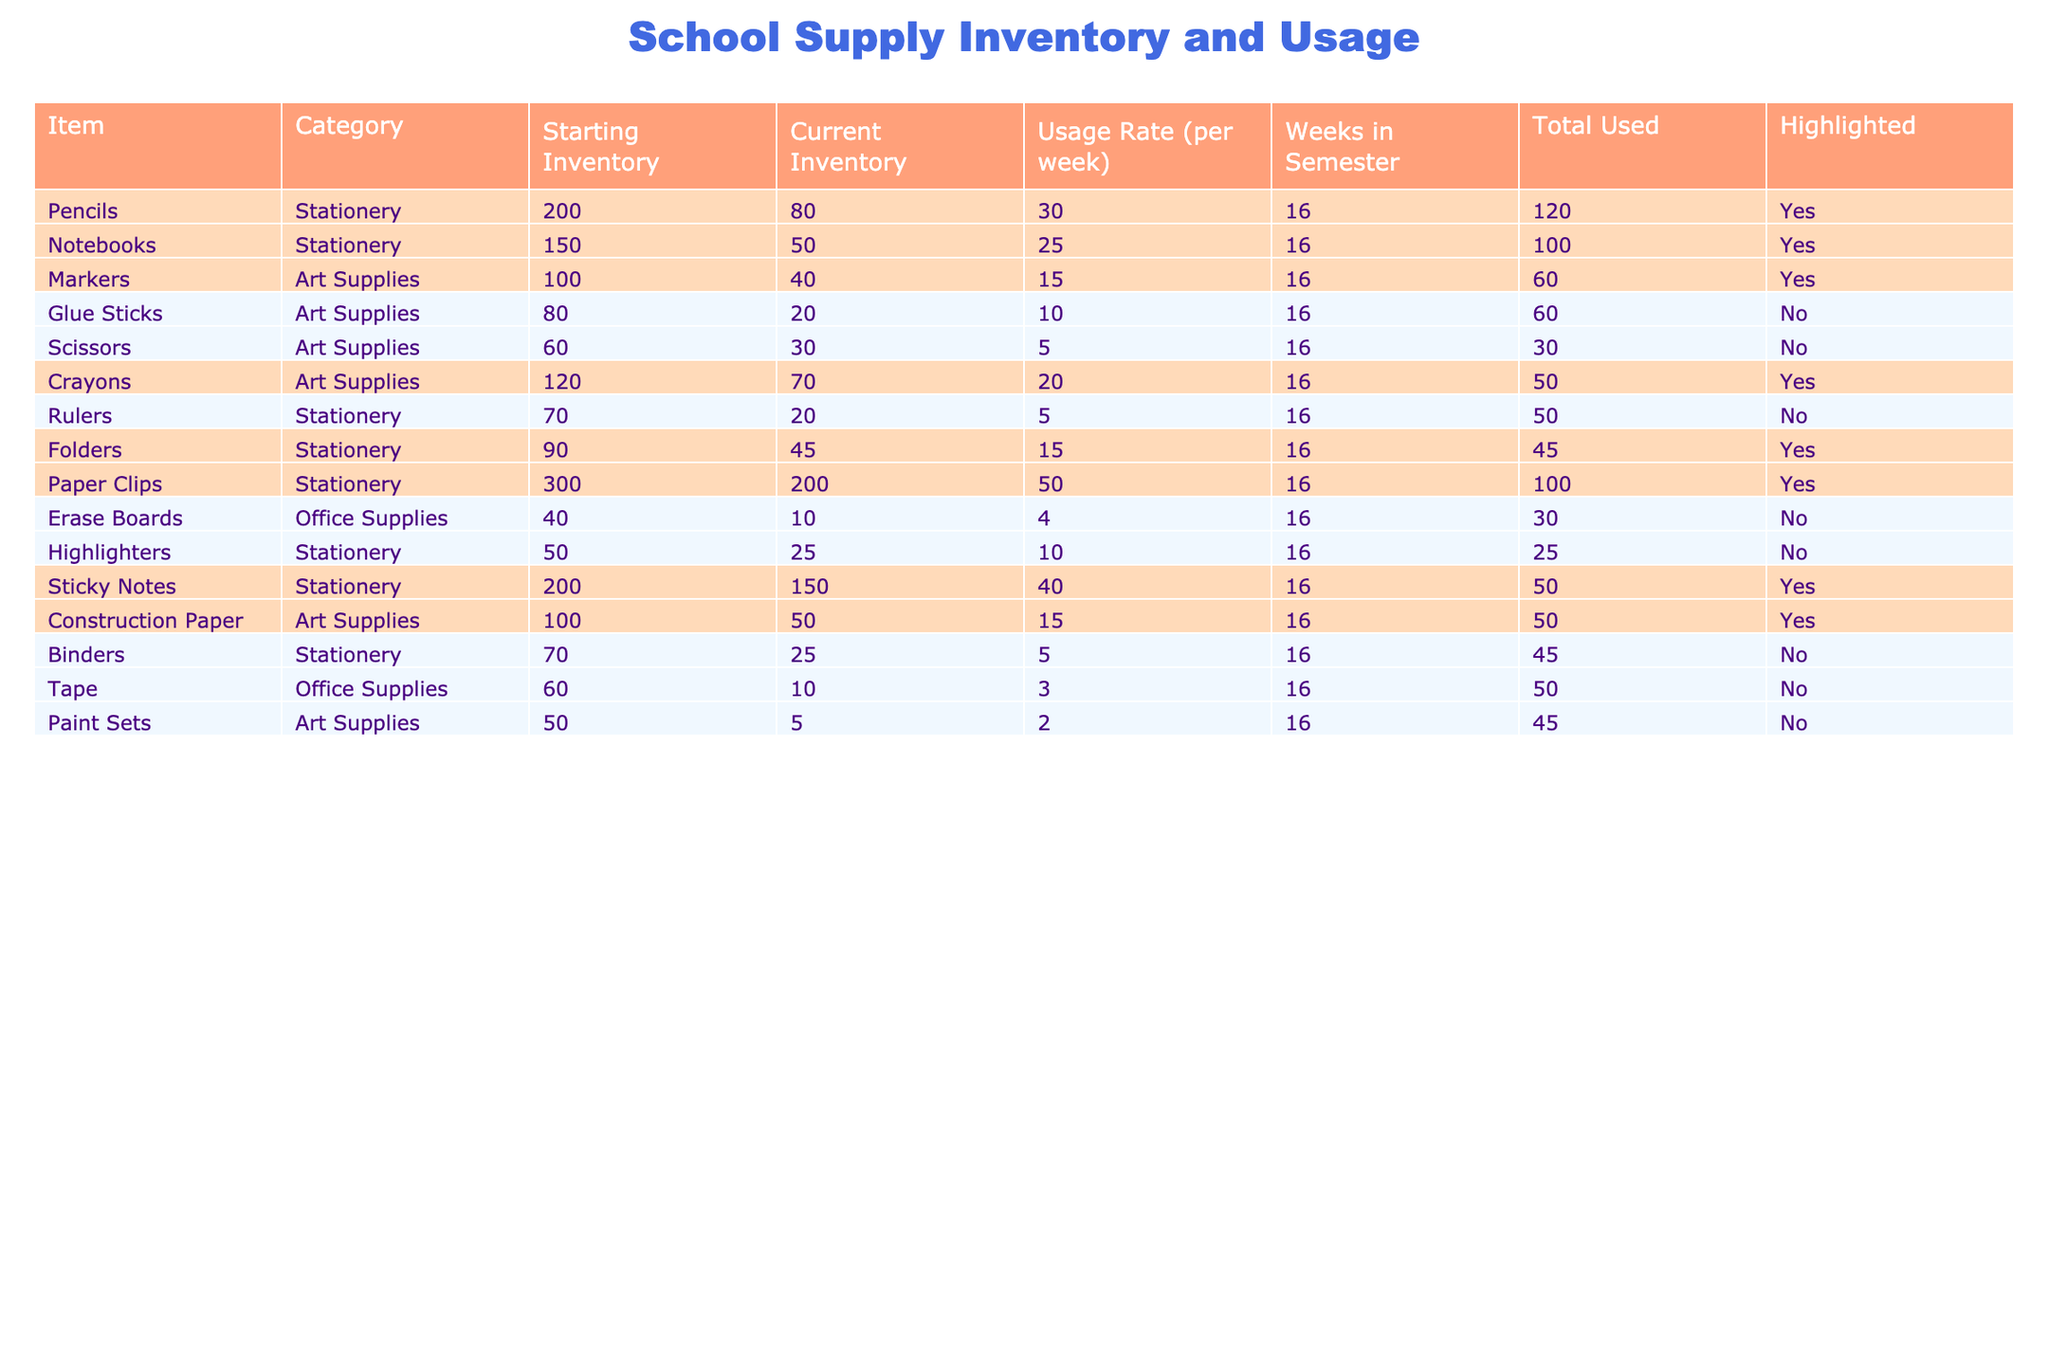What is the starting inventory of Pencils? The starting inventory of Pencils is listed in the table under the "Starting Inventory" column, where it shows a value of 200.
Answer: 200 How many Notebooks have been used this semester? The total used for Notebooks is provided in the "Total Used" column, where it states that 400 Notebooks have been used.
Answer: 400 Which item currently has the highest usage rate per week? By comparing the "Usage Rate (per week)" column, the item with the highest rate is Pencils with a usage rate of 30.
Answer: Pencils How many total Crayons are currently in inventory? The current inventory of Crayons is found in the "Current Inventory" column, showing a total of 70.
Answer: 70 Is the total used for Glue Sticks greater than 150? Looking at the "Total Used" column for Glue Sticks, the total used is 160, which is indeed greater than 150.
Answer: Yes What is the total inventory left for Stationery items after usage? Summing the current inventories for Stationery (Pencils, Notebooks, Rulers, Folders, Paper Clips, and Highlighters) gives (80 + 50 + 20 + 45 + 200 + 25 = 420).
Answer: 420 Which Art Supplies item has the lowest current inventory? By examining the "Current Inventory" for Art Supplies, Paint Sets have the lowest inventory at 5.
Answer: Paint Sets Calculate the total number of items highlighted in the table. The highlighted items are Pencils, Notebooks, Markers, Crayons, Folders, Paper Clips, Sticky Notes, and Construction Paper, totaling 8 items.
Answer: 8 What is the total amount of inventory remaining for all items classified as Office Supplies? The remaining inventory for Office Supplies (Erase Boards and Tape) totals (10 + 10 = 20).
Answer: 20 Are there more total used items for Stationery or Art Supplies? The total used for Stationery items is (480 + 400 + 80 + 240 + 800 + 160 = 2160), while Art Supplies total (240 + 320 + 160 + 32 = 752). Since 2160 > 752, the answer is Stationery.
Answer: Stationery How many items have a current inventory that is less than their starting inventory? By assessing each item in the table, Pencils, Notebooks, Markers, Crayons, Folders, and Sticky Notes are all less than their starting inventory, totaling 6 items.
Answer: 6 